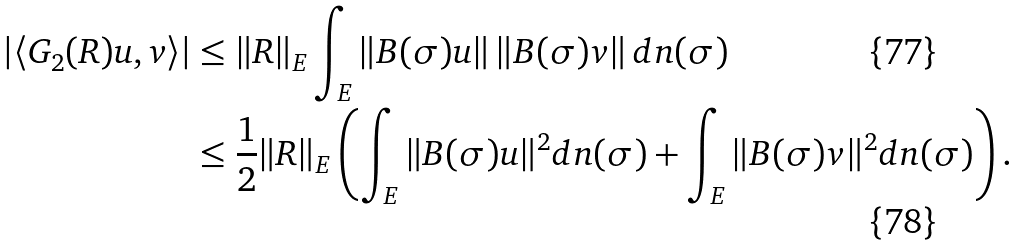Convert formula to latex. <formula><loc_0><loc_0><loc_500><loc_500>| \langle G _ { 2 } ( R ) u , v \rangle | & \leq \| R \| _ { E } \int _ { E } \| B ( \sigma ) u \| \, \| B ( \sigma ) v \| \, d n ( \sigma ) \\ & \leq \frac { 1 } { 2 } \| R \| _ { E } \left ( \int _ { E } \| B ( \sigma ) u \| ^ { 2 } d n ( \sigma ) + \int _ { E } \| B ( \sigma ) v \| ^ { 2 } d n ( \sigma ) \right ) .</formula> 